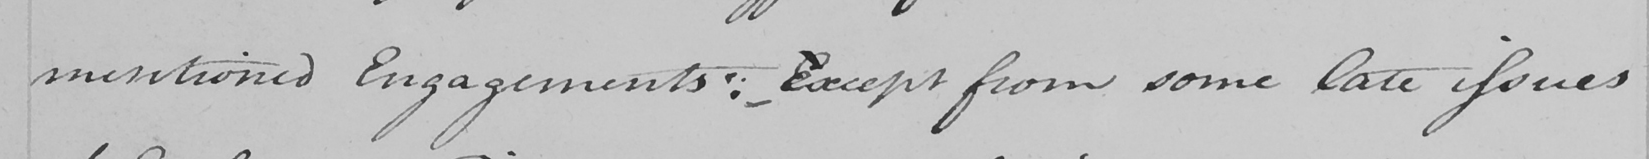What text is written in this handwritten line? mentioned Engagements :   _ - Eexcept from some late issues 